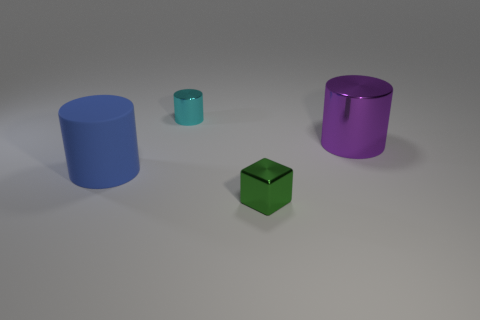There is a small thing left of the metal thing that is in front of the large blue rubber thing; is there a tiny cyan metal cylinder on the left side of it? no 